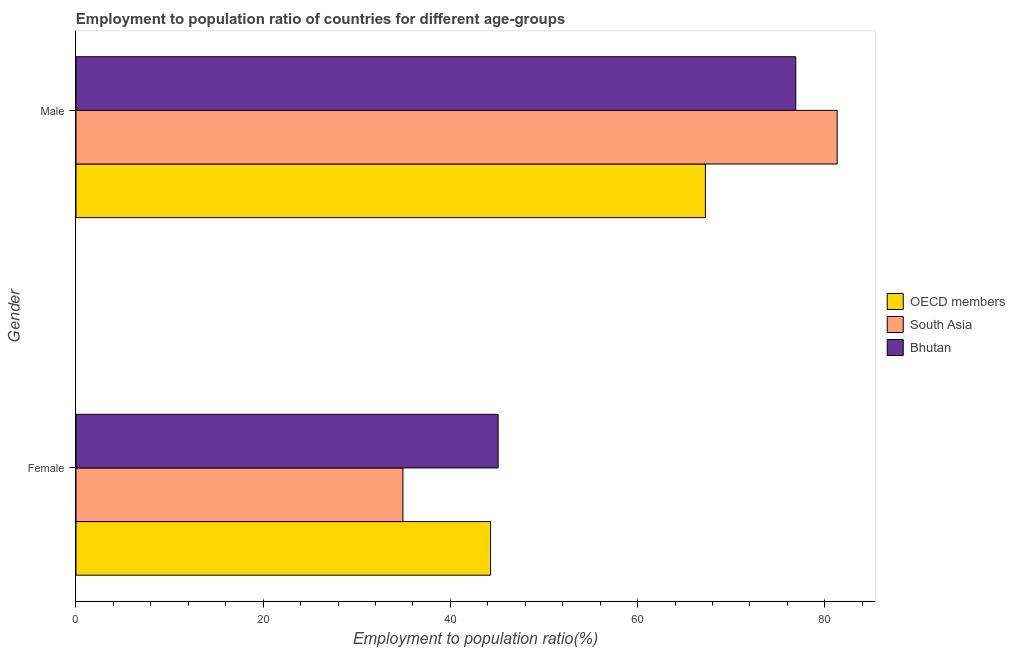How many different coloured bars are there?
Your response must be concise. 3. Are the number of bars per tick equal to the number of legend labels?
Make the answer very short. Yes. Are the number of bars on each tick of the Y-axis equal?
Provide a short and direct response. Yes. How many bars are there on the 2nd tick from the bottom?
Provide a short and direct response. 3. What is the label of the 2nd group of bars from the top?
Your response must be concise. Female. What is the employment to population ratio(male) in Bhutan?
Your response must be concise. 76.9. Across all countries, what is the maximum employment to population ratio(female)?
Offer a very short reply. 45.1. Across all countries, what is the minimum employment to population ratio(female)?
Your answer should be very brief. 34.93. What is the total employment to population ratio(female) in the graph?
Offer a very short reply. 124.32. What is the difference between the employment to population ratio(male) in OECD members and that in Bhutan?
Make the answer very short. -9.66. What is the difference between the employment to population ratio(male) in South Asia and the employment to population ratio(female) in Bhutan?
Your answer should be very brief. 36.22. What is the average employment to population ratio(male) per country?
Your answer should be compact. 75.16. What is the difference between the employment to population ratio(male) and employment to population ratio(female) in South Asia?
Ensure brevity in your answer.  46.39. What is the ratio of the employment to population ratio(male) in South Asia to that in Bhutan?
Your answer should be compact. 1.06. Is the employment to population ratio(female) in OECD members less than that in Bhutan?
Your response must be concise. Yes. In how many countries, is the employment to population ratio(male) greater than the average employment to population ratio(male) taken over all countries?
Your answer should be very brief. 2. What does the 3rd bar from the bottom in Male represents?
Your answer should be compact. Bhutan. How many countries are there in the graph?
Your response must be concise. 3. Are the values on the major ticks of X-axis written in scientific E-notation?
Keep it short and to the point. No. Does the graph contain any zero values?
Your response must be concise. No. How are the legend labels stacked?
Ensure brevity in your answer.  Vertical. What is the title of the graph?
Offer a very short reply. Employment to population ratio of countries for different age-groups. Does "Senegal" appear as one of the legend labels in the graph?
Provide a succinct answer. No. What is the label or title of the Y-axis?
Ensure brevity in your answer.  Gender. What is the Employment to population ratio(%) in OECD members in Female?
Your answer should be compact. 44.3. What is the Employment to population ratio(%) of South Asia in Female?
Provide a succinct answer. 34.93. What is the Employment to population ratio(%) of Bhutan in Female?
Provide a short and direct response. 45.1. What is the Employment to population ratio(%) of OECD members in Male?
Make the answer very short. 67.24. What is the Employment to population ratio(%) of South Asia in Male?
Give a very brief answer. 81.32. What is the Employment to population ratio(%) of Bhutan in Male?
Your response must be concise. 76.9. Across all Gender, what is the maximum Employment to population ratio(%) in OECD members?
Offer a very short reply. 67.24. Across all Gender, what is the maximum Employment to population ratio(%) in South Asia?
Provide a succinct answer. 81.32. Across all Gender, what is the maximum Employment to population ratio(%) of Bhutan?
Offer a terse response. 76.9. Across all Gender, what is the minimum Employment to population ratio(%) in OECD members?
Keep it short and to the point. 44.3. Across all Gender, what is the minimum Employment to population ratio(%) of South Asia?
Provide a succinct answer. 34.93. Across all Gender, what is the minimum Employment to population ratio(%) of Bhutan?
Your answer should be very brief. 45.1. What is the total Employment to population ratio(%) in OECD members in the graph?
Offer a terse response. 111.54. What is the total Employment to population ratio(%) in South Asia in the graph?
Your answer should be very brief. 116.25. What is the total Employment to population ratio(%) of Bhutan in the graph?
Provide a succinct answer. 122. What is the difference between the Employment to population ratio(%) of OECD members in Female and that in Male?
Your answer should be very brief. -22.95. What is the difference between the Employment to population ratio(%) in South Asia in Female and that in Male?
Keep it short and to the point. -46.39. What is the difference between the Employment to population ratio(%) in Bhutan in Female and that in Male?
Ensure brevity in your answer.  -31.8. What is the difference between the Employment to population ratio(%) of OECD members in Female and the Employment to population ratio(%) of South Asia in Male?
Keep it short and to the point. -37.03. What is the difference between the Employment to population ratio(%) in OECD members in Female and the Employment to population ratio(%) in Bhutan in Male?
Make the answer very short. -32.6. What is the difference between the Employment to population ratio(%) of South Asia in Female and the Employment to population ratio(%) of Bhutan in Male?
Keep it short and to the point. -41.97. What is the average Employment to population ratio(%) of OECD members per Gender?
Give a very brief answer. 55.77. What is the average Employment to population ratio(%) of South Asia per Gender?
Provide a succinct answer. 58.13. What is the difference between the Employment to population ratio(%) of OECD members and Employment to population ratio(%) of South Asia in Female?
Make the answer very short. 9.37. What is the difference between the Employment to population ratio(%) in OECD members and Employment to population ratio(%) in Bhutan in Female?
Provide a succinct answer. -0.8. What is the difference between the Employment to population ratio(%) in South Asia and Employment to population ratio(%) in Bhutan in Female?
Offer a very short reply. -10.17. What is the difference between the Employment to population ratio(%) in OECD members and Employment to population ratio(%) in South Asia in Male?
Make the answer very short. -14.08. What is the difference between the Employment to population ratio(%) of OECD members and Employment to population ratio(%) of Bhutan in Male?
Provide a succinct answer. -9.66. What is the difference between the Employment to population ratio(%) in South Asia and Employment to population ratio(%) in Bhutan in Male?
Provide a succinct answer. 4.42. What is the ratio of the Employment to population ratio(%) in OECD members in Female to that in Male?
Offer a terse response. 0.66. What is the ratio of the Employment to population ratio(%) in South Asia in Female to that in Male?
Your answer should be compact. 0.43. What is the ratio of the Employment to population ratio(%) of Bhutan in Female to that in Male?
Your response must be concise. 0.59. What is the difference between the highest and the second highest Employment to population ratio(%) in OECD members?
Offer a very short reply. 22.95. What is the difference between the highest and the second highest Employment to population ratio(%) of South Asia?
Offer a terse response. 46.39. What is the difference between the highest and the second highest Employment to population ratio(%) of Bhutan?
Provide a short and direct response. 31.8. What is the difference between the highest and the lowest Employment to population ratio(%) of OECD members?
Provide a succinct answer. 22.95. What is the difference between the highest and the lowest Employment to population ratio(%) in South Asia?
Your answer should be compact. 46.39. What is the difference between the highest and the lowest Employment to population ratio(%) of Bhutan?
Your answer should be very brief. 31.8. 